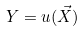Convert formula to latex. <formula><loc_0><loc_0><loc_500><loc_500>Y = u ( \vec { X } )</formula> 